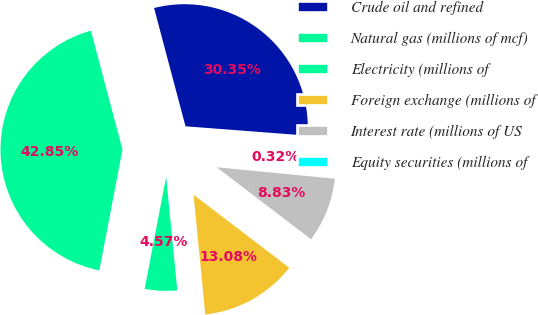Convert chart to OTSL. <chart><loc_0><loc_0><loc_500><loc_500><pie_chart><fcel>Crude oil and refined<fcel>Natural gas (millions of mcf)<fcel>Electricity (millions of<fcel>Foreign exchange (millions of<fcel>Interest rate (millions of US<fcel>Equity securities (millions of<nl><fcel>30.35%<fcel>42.85%<fcel>4.57%<fcel>13.08%<fcel>8.83%<fcel>0.32%<nl></chart> 